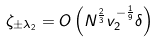Convert formula to latex. <formula><loc_0><loc_0><loc_500><loc_500>\zeta _ { \pm \lambda _ { 2 } } = O \left ( N ^ { \frac { 2 } { 3 } } v _ { 2 } ^ { - \frac { 1 } { 9 } } \delta \right )</formula> 